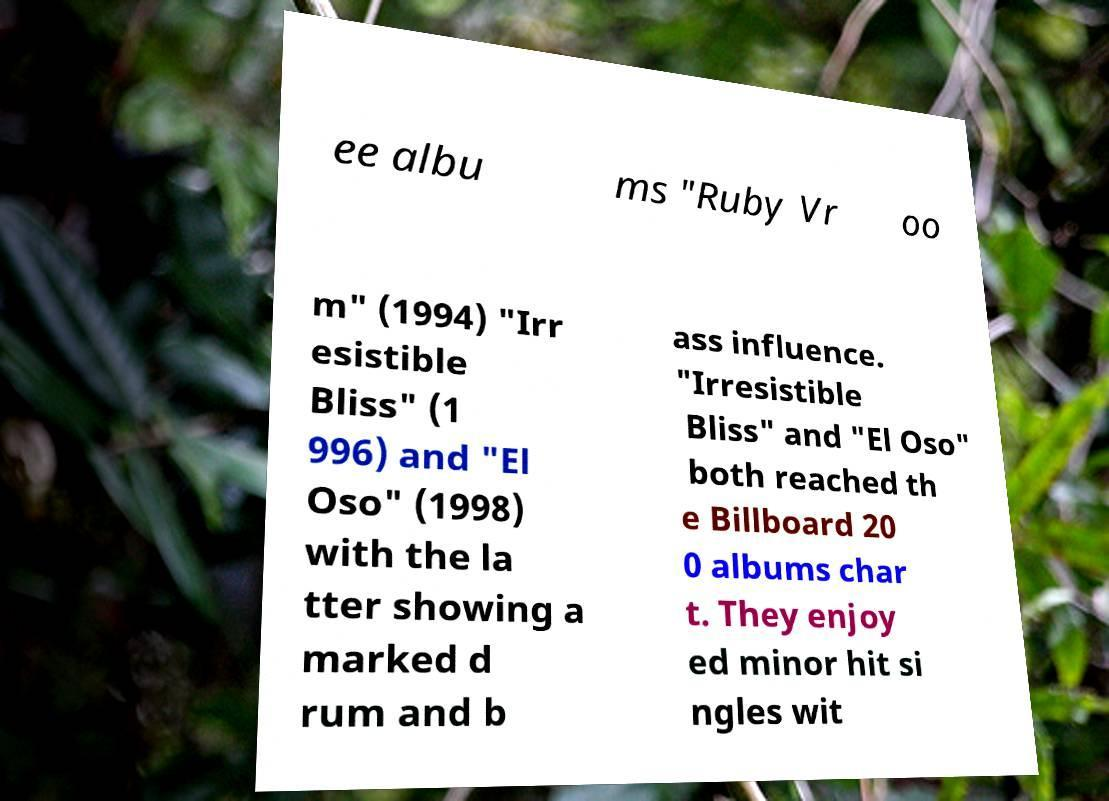Could you assist in decoding the text presented in this image and type it out clearly? ee albu ms "Ruby Vr oo m" (1994) "Irr esistible Bliss" (1 996) and "El Oso" (1998) with the la tter showing a marked d rum and b ass influence. "Irresistible Bliss" and "El Oso" both reached th e Billboard 20 0 albums char t. They enjoy ed minor hit si ngles wit 